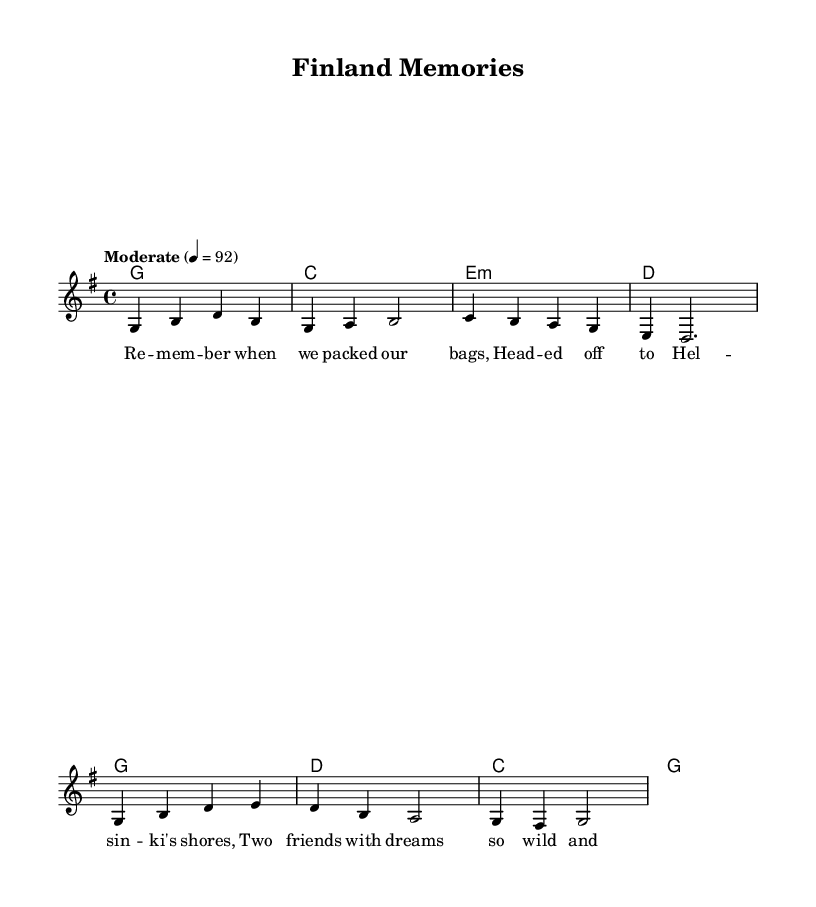What is the key signature of this music? The key signature is G major, which has one sharp (F#). This can be confirmed by looking at the key indication at the beginning of the sheet music.
Answer: G major What is the time signature of this music? The time signature is 4/4, which means there are four beats per measure and each quarter note receives one beat. This is indicated at the start of the music.
Answer: 4/4 What is the tempo marking for this piece? The tempo marking is "Moderate" at a speed of 92 beats per minute. This indicates how fast the music should be played and is found near the beginning of the score.
Answer: Moderate 4 = 92 How many measures are in the melody section? The melody section contains eight measures. By counting the vertical lines that separate the measures in the score, we find a total of eight.
Answer: 8 What type of musical form does this song follow? The song seems to follow a verse-chorus form, typical in country music. This can be inferred from the presence of distinct verses and a repeating chorus in the lyrics.
Answer: Verse-chorus What is the primary theme expressed in the lyrics? The primary theme expressed in the lyrics is about lifelong friendships and shared adventures, reflecting fond memories of experiences in Finland. This can be deduced from the content of the lyrics themselves.
Answer: Lifelong friendships 